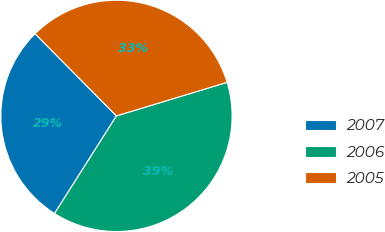Convert chart. <chart><loc_0><loc_0><loc_500><loc_500><pie_chart><fcel>2007<fcel>2006<fcel>2005<nl><fcel>28.58%<fcel>38.69%<fcel>32.73%<nl></chart> 